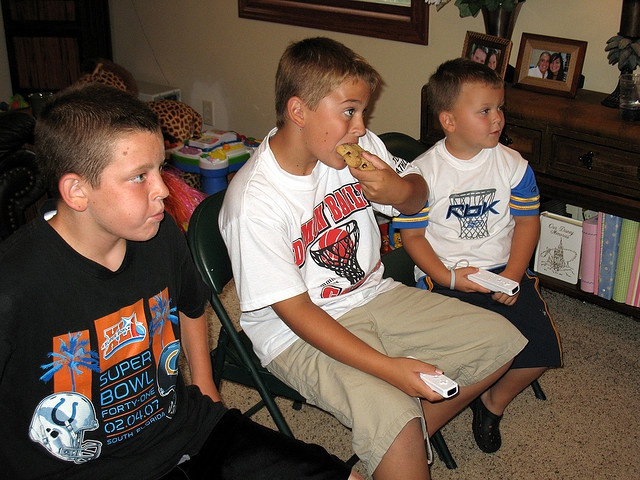Describe the objects in this image and their specific colors. I can see people in black, salmon, brown, and tan tones, people in black, white, tan, and gray tones, people in black, lightgray, and brown tones, chair in black, gray, maroon, and darkgray tones, and chair in black and gray tones in this image. 